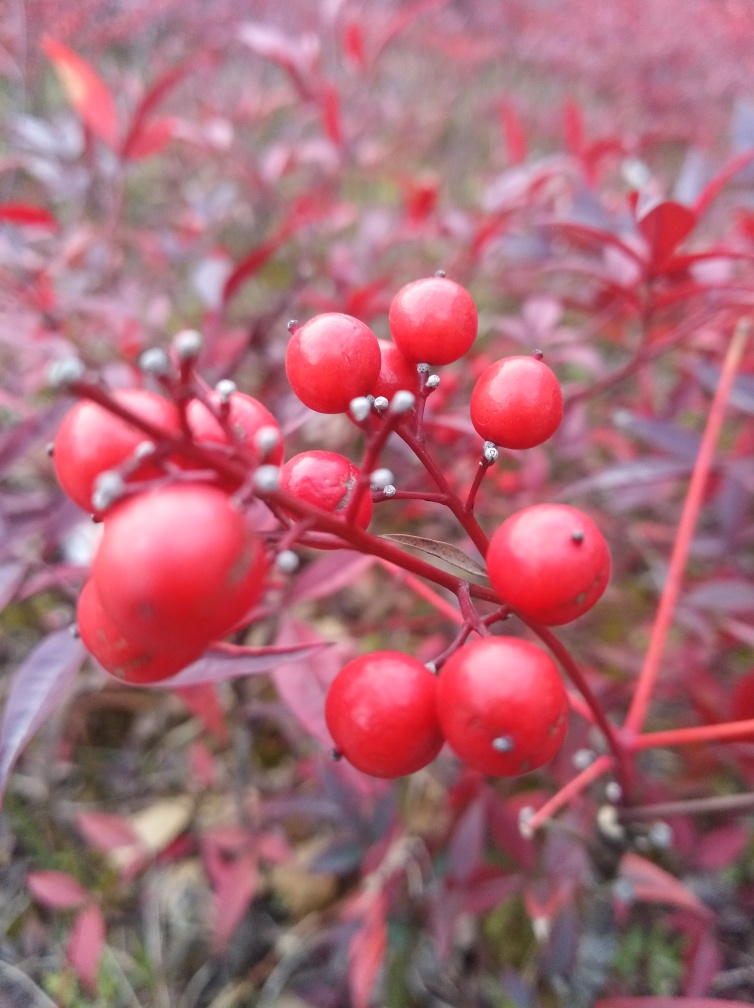What season does this image likely depict? The vibrant red leaves and berries suggest that this image is likely captured during autumn, a season when many plants change color before shedding their leaves for the winter. 